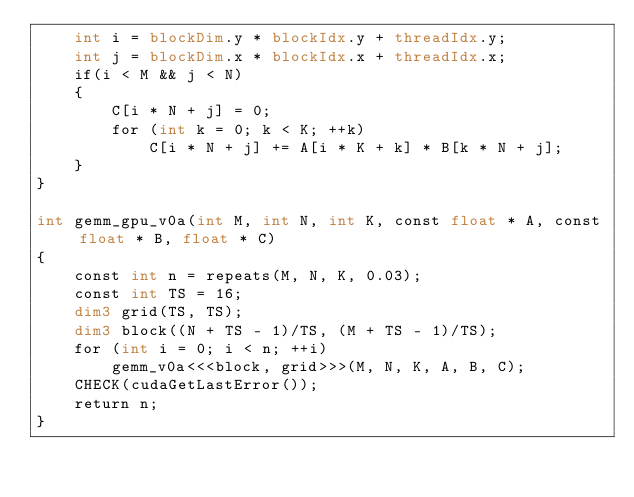<code> <loc_0><loc_0><loc_500><loc_500><_Cuda_>    int i = blockDim.y * blockIdx.y + threadIdx.y;
    int j = blockDim.x * blockIdx.x + threadIdx.x;
    if(i < M && j < N)
    {
        C[i * N + j] = 0;
        for (int k = 0; k < K; ++k)
            C[i * N + j] += A[i * K + k] * B[k * N + j];
    }
}

int gemm_gpu_v0a(int M, int N, int K, const float * A, const float * B, float * C)
{
    const int n = repeats(M, N, K, 0.03);
    const int TS = 16;
    dim3 grid(TS, TS);
    dim3 block((N + TS - 1)/TS, (M + TS - 1)/TS);
    for (int i = 0; i < n; ++i)
        gemm_v0a<<<block, grid>>>(M, N, K, A, B, C);
    CHECK(cudaGetLastError());
    return n;
}</code> 